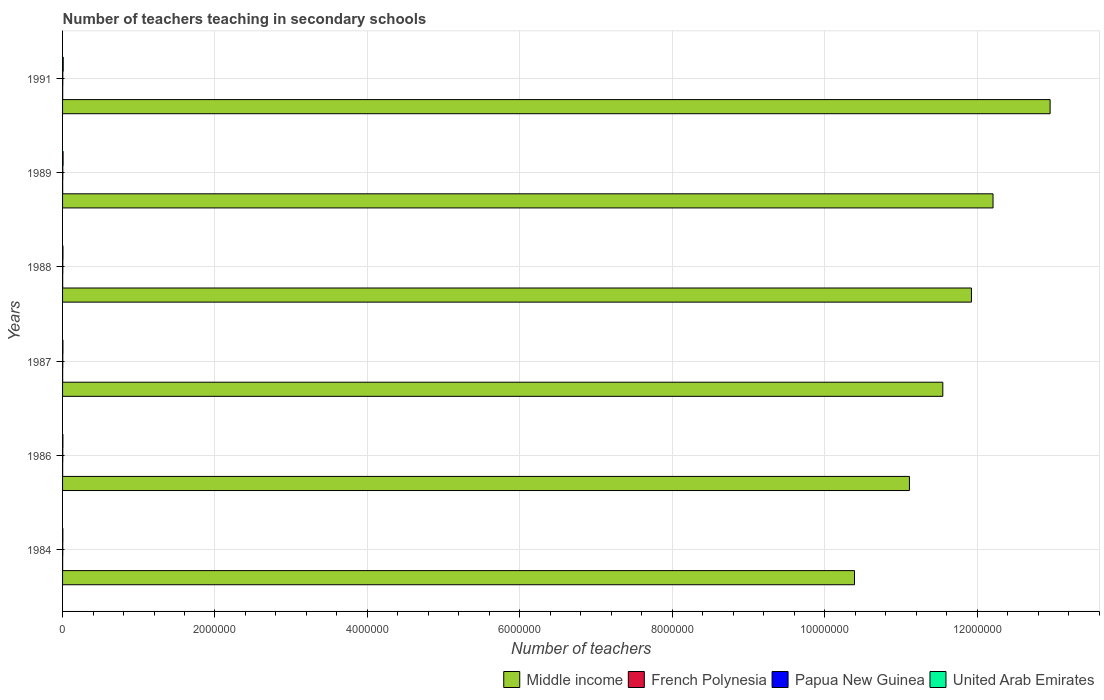How many different coloured bars are there?
Provide a succinct answer. 4. How many groups of bars are there?
Provide a short and direct response. 6. Are the number of bars per tick equal to the number of legend labels?
Provide a succinct answer. Yes. Are the number of bars on each tick of the Y-axis equal?
Offer a very short reply. Yes. How many bars are there on the 1st tick from the bottom?
Keep it short and to the point. 4. In how many cases, is the number of bars for a given year not equal to the number of legend labels?
Ensure brevity in your answer.  0. What is the number of teachers teaching in secondary schools in Middle income in 1988?
Provide a succinct answer. 1.19e+07. Across all years, what is the maximum number of teachers teaching in secondary schools in Middle income?
Provide a short and direct response. 1.30e+07. Across all years, what is the minimum number of teachers teaching in secondary schools in Middle income?
Your response must be concise. 1.04e+07. What is the total number of teachers teaching in secondary schools in Middle income in the graph?
Ensure brevity in your answer.  7.01e+07. What is the difference between the number of teachers teaching in secondary schools in Middle income in 1987 and that in 1991?
Your answer should be compact. -1.41e+06. What is the difference between the number of teachers teaching in secondary schools in Middle income in 1988 and the number of teachers teaching in secondary schools in Papua New Guinea in 1989?
Give a very brief answer. 1.19e+07. What is the average number of teachers teaching in secondary schools in Middle income per year?
Your answer should be compact. 1.17e+07. In the year 1984, what is the difference between the number of teachers teaching in secondary schools in French Polynesia and number of teachers teaching in secondary schools in Papua New Guinea?
Your answer should be compact. -1327. In how many years, is the number of teachers teaching in secondary schools in Papua New Guinea greater than 8400000 ?
Offer a terse response. 0. What is the ratio of the number of teachers teaching in secondary schools in United Arab Emirates in 1987 to that in 1991?
Keep it short and to the point. 0.55. Is the number of teachers teaching in secondary schools in Papua New Guinea in 1986 less than that in 1987?
Provide a short and direct response. Yes. Is the difference between the number of teachers teaching in secondary schools in French Polynesia in 1984 and 1986 greater than the difference between the number of teachers teaching in secondary schools in Papua New Guinea in 1984 and 1986?
Ensure brevity in your answer.  Yes. What is the difference between the highest and the second highest number of teachers teaching in secondary schools in Middle income?
Your answer should be compact. 7.49e+05. What is the difference between the highest and the lowest number of teachers teaching in secondary schools in Middle income?
Offer a very short reply. 2.57e+06. Is the sum of the number of teachers teaching in secondary schools in United Arab Emirates in 1986 and 1989 greater than the maximum number of teachers teaching in secondary schools in Papua New Guinea across all years?
Offer a terse response. Yes. Is it the case that in every year, the sum of the number of teachers teaching in secondary schools in French Polynesia and number of teachers teaching in secondary schools in United Arab Emirates is greater than the sum of number of teachers teaching in secondary schools in Middle income and number of teachers teaching in secondary schools in Papua New Guinea?
Your answer should be compact. No. What does the 1st bar from the top in 1988 represents?
Provide a short and direct response. United Arab Emirates. What does the 1st bar from the bottom in 1991 represents?
Give a very brief answer. Middle income. Is it the case that in every year, the sum of the number of teachers teaching in secondary schools in United Arab Emirates and number of teachers teaching in secondary schools in Papua New Guinea is greater than the number of teachers teaching in secondary schools in French Polynesia?
Provide a succinct answer. Yes. How many bars are there?
Make the answer very short. 24. Does the graph contain any zero values?
Your response must be concise. No. Does the graph contain grids?
Offer a very short reply. Yes. How many legend labels are there?
Provide a short and direct response. 4. What is the title of the graph?
Ensure brevity in your answer.  Number of teachers teaching in secondary schools. What is the label or title of the X-axis?
Keep it short and to the point. Number of teachers. What is the label or title of the Y-axis?
Provide a succinct answer. Years. What is the Number of teachers in Middle income in 1984?
Keep it short and to the point. 1.04e+07. What is the Number of teachers of French Polynesia in 1984?
Offer a terse response. 1051. What is the Number of teachers in Papua New Guinea in 1984?
Offer a terse response. 2378. What is the Number of teachers of United Arab Emirates in 1984?
Your response must be concise. 3735. What is the Number of teachers of Middle income in 1986?
Make the answer very short. 1.11e+07. What is the Number of teachers of French Polynesia in 1986?
Your answer should be very brief. 1208. What is the Number of teachers of Papua New Guinea in 1986?
Your answer should be compact. 2549. What is the Number of teachers in United Arab Emirates in 1986?
Give a very brief answer. 4237. What is the Number of teachers of Middle income in 1987?
Offer a terse response. 1.16e+07. What is the Number of teachers of French Polynesia in 1987?
Provide a succinct answer. 1240. What is the Number of teachers in Papua New Guinea in 1987?
Your answer should be very brief. 2922. What is the Number of teachers in United Arab Emirates in 1987?
Your answer should be compact. 4724. What is the Number of teachers of Middle income in 1988?
Provide a succinct answer. 1.19e+07. What is the Number of teachers in French Polynesia in 1988?
Offer a very short reply. 1296. What is the Number of teachers of Papua New Guinea in 1988?
Make the answer very short. 3064. What is the Number of teachers of United Arab Emirates in 1988?
Ensure brevity in your answer.  5008. What is the Number of teachers in Middle income in 1989?
Your answer should be very brief. 1.22e+07. What is the Number of teachers in French Polynesia in 1989?
Keep it short and to the point. 1290. What is the Number of teachers of Papua New Guinea in 1989?
Provide a short and direct response. 3057. What is the Number of teachers of United Arab Emirates in 1989?
Make the answer very short. 6875. What is the Number of teachers of Middle income in 1991?
Keep it short and to the point. 1.30e+07. What is the Number of teachers in French Polynesia in 1991?
Offer a terse response. 1497. What is the Number of teachers of Papua New Guinea in 1991?
Ensure brevity in your answer.  3120. What is the Number of teachers of United Arab Emirates in 1991?
Provide a succinct answer. 8565. Across all years, what is the maximum Number of teachers of Middle income?
Offer a terse response. 1.30e+07. Across all years, what is the maximum Number of teachers in French Polynesia?
Ensure brevity in your answer.  1497. Across all years, what is the maximum Number of teachers in Papua New Guinea?
Provide a succinct answer. 3120. Across all years, what is the maximum Number of teachers in United Arab Emirates?
Provide a short and direct response. 8565. Across all years, what is the minimum Number of teachers in Middle income?
Provide a succinct answer. 1.04e+07. Across all years, what is the minimum Number of teachers in French Polynesia?
Provide a short and direct response. 1051. Across all years, what is the minimum Number of teachers in Papua New Guinea?
Your answer should be very brief. 2378. Across all years, what is the minimum Number of teachers of United Arab Emirates?
Provide a succinct answer. 3735. What is the total Number of teachers of Middle income in the graph?
Offer a very short reply. 7.01e+07. What is the total Number of teachers of French Polynesia in the graph?
Offer a terse response. 7582. What is the total Number of teachers in Papua New Guinea in the graph?
Provide a short and direct response. 1.71e+04. What is the total Number of teachers in United Arab Emirates in the graph?
Provide a short and direct response. 3.31e+04. What is the difference between the Number of teachers of Middle income in 1984 and that in 1986?
Provide a short and direct response. -7.21e+05. What is the difference between the Number of teachers of French Polynesia in 1984 and that in 1986?
Give a very brief answer. -157. What is the difference between the Number of teachers in Papua New Guinea in 1984 and that in 1986?
Give a very brief answer. -171. What is the difference between the Number of teachers in United Arab Emirates in 1984 and that in 1986?
Your answer should be very brief. -502. What is the difference between the Number of teachers in Middle income in 1984 and that in 1987?
Make the answer very short. -1.16e+06. What is the difference between the Number of teachers of French Polynesia in 1984 and that in 1987?
Provide a short and direct response. -189. What is the difference between the Number of teachers in Papua New Guinea in 1984 and that in 1987?
Offer a very short reply. -544. What is the difference between the Number of teachers in United Arab Emirates in 1984 and that in 1987?
Offer a very short reply. -989. What is the difference between the Number of teachers of Middle income in 1984 and that in 1988?
Provide a succinct answer. -1.53e+06. What is the difference between the Number of teachers in French Polynesia in 1984 and that in 1988?
Your answer should be compact. -245. What is the difference between the Number of teachers of Papua New Guinea in 1984 and that in 1988?
Keep it short and to the point. -686. What is the difference between the Number of teachers in United Arab Emirates in 1984 and that in 1988?
Keep it short and to the point. -1273. What is the difference between the Number of teachers of Middle income in 1984 and that in 1989?
Offer a terse response. -1.82e+06. What is the difference between the Number of teachers in French Polynesia in 1984 and that in 1989?
Ensure brevity in your answer.  -239. What is the difference between the Number of teachers of Papua New Guinea in 1984 and that in 1989?
Your response must be concise. -679. What is the difference between the Number of teachers of United Arab Emirates in 1984 and that in 1989?
Offer a terse response. -3140. What is the difference between the Number of teachers of Middle income in 1984 and that in 1991?
Give a very brief answer. -2.57e+06. What is the difference between the Number of teachers in French Polynesia in 1984 and that in 1991?
Provide a succinct answer. -446. What is the difference between the Number of teachers in Papua New Guinea in 1984 and that in 1991?
Provide a short and direct response. -742. What is the difference between the Number of teachers in United Arab Emirates in 1984 and that in 1991?
Offer a very short reply. -4830. What is the difference between the Number of teachers in Middle income in 1986 and that in 1987?
Provide a short and direct response. -4.38e+05. What is the difference between the Number of teachers in French Polynesia in 1986 and that in 1987?
Provide a short and direct response. -32. What is the difference between the Number of teachers of Papua New Guinea in 1986 and that in 1987?
Provide a short and direct response. -373. What is the difference between the Number of teachers of United Arab Emirates in 1986 and that in 1987?
Provide a short and direct response. -487. What is the difference between the Number of teachers in Middle income in 1986 and that in 1988?
Offer a very short reply. -8.13e+05. What is the difference between the Number of teachers of French Polynesia in 1986 and that in 1988?
Give a very brief answer. -88. What is the difference between the Number of teachers in Papua New Guinea in 1986 and that in 1988?
Offer a terse response. -515. What is the difference between the Number of teachers in United Arab Emirates in 1986 and that in 1988?
Offer a very short reply. -771. What is the difference between the Number of teachers in Middle income in 1986 and that in 1989?
Your answer should be compact. -1.10e+06. What is the difference between the Number of teachers of French Polynesia in 1986 and that in 1989?
Give a very brief answer. -82. What is the difference between the Number of teachers of Papua New Guinea in 1986 and that in 1989?
Your response must be concise. -508. What is the difference between the Number of teachers in United Arab Emirates in 1986 and that in 1989?
Your answer should be very brief. -2638. What is the difference between the Number of teachers in Middle income in 1986 and that in 1991?
Your answer should be very brief. -1.85e+06. What is the difference between the Number of teachers of French Polynesia in 1986 and that in 1991?
Your answer should be compact. -289. What is the difference between the Number of teachers of Papua New Guinea in 1986 and that in 1991?
Your answer should be very brief. -571. What is the difference between the Number of teachers in United Arab Emirates in 1986 and that in 1991?
Provide a succinct answer. -4328. What is the difference between the Number of teachers in Middle income in 1987 and that in 1988?
Your response must be concise. -3.76e+05. What is the difference between the Number of teachers of French Polynesia in 1987 and that in 1988?
Your answer should be compact. -56. What is the difference between the Number of teachers in Papua New Guinea in 1987 and that in 1988?
Ensure brevity in your answer.  -142. What is the difference between the Number of teachers of United Arab Emirates in 1987 and that in 1988?
Provide a short and direct response. -284. What is the difference between the Number of teachers in Middle income in 1987 and that in 1989?
Ensure brevity in your answer.  -6.59e+05. What is the difference between the Number of teachers in French Polynesia in 1987 and that in 1989?
Keep it short and to the point. -50. What is the difference between the Number of teachers in Papua New Guinea in 1987 and that in 1989?
Your response must be concise. -135. What is the difference between the Number of teachers of United Arab Emirates in 1987 and that in 1989?
Ensure brevity in your answer.  -2151. What is the difference between the Number of teachers of Middle income in 1987 and that in 1991?
Your answer should be compact. -1.41e+06. What is the difference between the Number of teachers in French Polynesia in 1987 and that in 1991?
Offer a very short reply. -257. What is the difference between the Number of teachers in Papua New Guinea in 1987 and that in 1991?
Your answer should be compact. -198. What is the difference between the Number of teachers of United Arab Emirates in 1987 and that in 1991?
Ensure brevity in your answer.  -3841. What is the difference between the Number of teachers in Middle income in 1988 and that in 1989?
Your response must be concise. -2.83e+05. What is the difference between the Number of teachers of United Arab Emirates in 1988 and that in 1989?
Give a very brief answer. -1867. What is the difference between the Number of teachers of Middle income in 1988 and that in 1991?
Give a very brief answer. -1.03e+06. What is the difference between the Number of teachers in French Polynesia in 1988 and that in 1991?
Keep it short and to the point. -201. What is the difference between the Number of teachers in Papua New Guinea in 1988 and that in 1991?
Offer a terse response. -56. What is the difference between the Number of teachers in United Arab Emirates in 1988 and that in 1991?
Offer a terse response. -3557. What is the difference between the Number of teachers of Middle income in 1989 and that in 1991?
Your answer should be very brief. -7.49e+05. What is the difference between the Number of teachers in French Polynesia in 1989 and that in 1991?
Your answer should be compact. -207. What is the difference between the Number of teachers in Papua New Guinea in 1989 and that in 1991?
Provide a short and direct response. -63. What is the difference between the Number of teachers in United Arab Emirates in 1989 and that in 1991?
Provide a short and direct response. -1690. What is the difference between the Number of teachers of Middle income in 1984 and the Number of teachers of French Polynesia in 1986?
Offer a terse response. 1.04e+07. What is the difference between the Number of teachers of Middle income in 1984 and the Number of teachers of Papua New Guinea in 1986?
Offer a very short reply. 1.04e+07. What is the difference between the Number of teachers in Middle income in 1984 and the Number of teachers in United Arab Emirates in 1986?
Provide a succinct answer. 1.04e+07. What is the difference between the Number of teachers of French Polynesia in 1984 and the Number of teachers of Papua New Guinea in 1986?
Make the answer very short. -1498. What is the difference between the Number of teachers of French Polynesia in 1984 and the Number of teachers of United Arab Emirates in 1986?
Provide a short and direct response. -3186. What is the difference between the Number of teachers in Papua New Guinea in 1984 and the Number of teachers in United Arab Emirates in 1986?
Provide a succinct answer. -1859. What is the difference between the Number of teachers of Middle income in 1984 and the Number of teachers of French Polynesia in 1987?
Keep it short and to the point. 1.04e+07. What is the difference between the Number of teachers in Middle income in 1984 and the Number of teachers in Papua New Guinea in 1987?
Provide a short and direct response. 1.04e+07. What is the difference between the Number of teachers in Middle income in 1984 and the Number of teachers in United Arab Emirates in 1987?
Provide a short and direct response. 1.04e+07. What is the difference between the Number of teachers in French Polynesia in 1984 and the Number of teachers in Papua New Guinea in 1987?
Give a very brief answer. -1871. What is the difference between the Number of teachers of French Polynesia in 1984 and the Number of teachers of United Arab Emirates in 1987?
Give a very brief answer. -3673. What is the difference between the Number of teachers in Papua New Guinea in 1984 and the Number of teachers in United Arab Emirates in 1987?
Ensure brevity in your answer.  -2346. What is the difference between the Number of teachers of Middle income in 1984 and the Number of teachers of French Polynesia in 1988?
Offer a terse response. 1.04e+07. What is the difference between the Number of teachers in Middle income in 1984 and the Number of teachers in Papua New Guinea in 1988?
Keep it short and to the point. 1.04e+07. What is the difference between the Number of teachers of Middle income in 1984 and the Number of teachers of United Arab Emirates in 1988?
Your response must be concise. 1.04e+07. What is the difference between the Number of teachers in French Polynesia in 1984 and the Number of teachers in Papua New Guinea in 1988?
Offer a very short reply. -2013. What is the difference between the Number of teachers of French Polynesia in 1984 and the Number of teachers of United Arab Emirates in 1988?
Provide a succinct answer. -3957. What is the difference between the Number of teachers in Papua New Guinea in 1984 and the Number of teachers in United Arab Emirates in 1988?
Give a very brief answer. -2630. What is the difference between the Number of teachers in Middle income in 1984 and the Number of teachers in French Polynesia in 1989?
Give a very brief answer. 1.04e+07. What is the difference between the Number of teachers in Middle income in 1984 and the Number of teachers in Papua New Guinea in 1989?
Offer a terse response. 1.04e+07. What is the difference between the Number of teachers in Middle income in 1984 and the Number of teachers in United Arab Emirates in 1989?
Your answer should be very brief. 1.04e+07. What is the difference between the Number of teachers in French Polynesia in 1984 and the Number of teachers in Papua New Guinea in 1989?
Provide a short and direct response. -2006. What is the difference between the Number of teachers in French Polynesia in 1984 and the Number of teachers in United Arab Emirates in 1989?
Offer a terse response. -5824. What is the difference between the Number of teachers of Papua New Guinea in 1984 and the Number of teachers of United Arab Emirates in 1989?
Give a very brief answer. -4497. What is the difference between the Number of teachers of Middle income in 1984 and the Number of teachers of French Polynesia in 1991?
Offer a terse response. 1.04e+07. What is the difference between the Number of teachers in Middle income in 1984 and the Number of teachers in Papua New Guinea in 1991?
Provide a short and direct response. 1.04e+07. What is the difference between the Number of teachers of Middle income in 1984 and the Number of teachers of United Arab Emirates in 1991?
Provide a succinct answer. 1.04e+07. What is the difference between the Number of teachers of French Polynesia in 1984 and the Number of teachers of Papua New Guinea in 1991?
Offer a very short reply. -2069. What is the difference between the Number of teachers in French Polynesia in 1984 and the Number of teachers in United Arab Emirates in 1991?
Your answer should be very brief. -7514. What is the difference between the Number of teachers of Papua New Guinea in 1984 and the Number of teachers of United Arab Emirates in 1991?
Give a very brief answer. -6187. What is the difference between the Number of teachers in Middle income in 1986 and the Number of teachers in French Polynesia in 1987?
Offer a terse response. 1.11e+07. What is the difference between the Number of teachers in Middle income in 1986 and the Number of teachers in Papua New Guinea in 1987?
Offer a very short reply. 1.11e+07. What is the difference between the Number of teachers of Middle income in 1986 and the Number of teachers of United Arab Emirates in 1987?
Your answer should be very brief. 1.11e+07. What is the difference between the Number of teachers in French Polynesia in 1986 and the Number of teachers in Papua New Guinea in 1987?
Give a very brief answer. -1714. What is the difference between the Number of teachers of French Polynesia in 1986 and the Number of teachers of United Arab Emirates in 1987?
Ensure brevity in your answer.  -3516. What is the difference between the Number of teachers in Papua New Guinea in 1986 and the Number of teachers in United Arab Emirates in 1987?
Provide a short and direct response. -2175. What is the difference between the Number of teachers in Middle income in 1986 and the Number of teachers in French Polynesia in 1988?
Ensure brevity in your answer.  1.11e+07. What is the difference between the Number of teachers of Middle income in 1986 and the Number of teachers of Papua New Guinea in 1988?
Keep it short and to the point. 1.11e+07. What is the difference between the Number of teachers of Middle income in 1986 and the Number of teachers of United Arab Emirates in 1988?
Your answer should be very brief. 1.11e+07. What is the difference between the Number of teachers in French Polynesia in 1986 and the Number of teachers in Papua New Guinea in 1988?
Give a very brief answer. -1856. What is the difference between the Number of teachers of French Polynesia in 1986 and the Number of teachers of United Arab Emirates in 1988?
Offer a very short reply. -3800. What is the difference between the Number of teachers in Papua New Guinea in 1986 and the Number of teachers in United Arab Emirates in 1988?
Your answer should be very brief. -2459. What is the difference between the Number of teachers of Middle income in 1986 and the Number of teachers of French Polynesia in 1989?
Provide a succinct answer. 1.11e+07. What is the difference between the Number of teachers in Middle income in 1986 and the Number of teachers in Papua New Guinea in 1989?
Provide a succinct answer. 1.11e+07. What is the difference between the Number of teachers of Middle income in 1986 and the Number of teachers of United Arab Emirates in 1989?
Ensure brevity in your answer.  1.11e+07. What is the difference between the Number of teachers of French Polynesia in 1986 and the Number of teachers of Papua New Guinea in 1989?
Offer a very short reply. -1849. What is the difference between the Number of teachers in French Polynesia in 1986 and the Number of teachers in United Arab Emirates in 1989?
Give a very brief answer. -5667. What is the difference between the Number of teachers in Papua New Guinea in 1986 and the Number of teachers in United Arab Emirates in 1989?
Provide a short and direct response. -4326. What is the difference between the Number of teachers in Middle income in 1986 and the Number of teachers in French Polynesia in 1991?
Your answer should be compact. 1.11e+07. What is the difference between the Number of teachers of Middle income in 1986 and the Number of teachers of Papua New Guinea in 1991?
Your answer should be compact. 1.11e+07. What is the difference between the Number of teachers of Middle income in 1986 and the Number of teachers of United Arab Emirates in 1991?
Your response must be concise. 1.11e+07. What is the difference between the Number of teachers of French Polynesia in 1986 and the Number of teachers of Papua New Guinea in 1991?
Provide a short and direct response. -1912. What is the difference between the Number of teachers in French Polynesia in 1986 and the Number of teachers in United Arab Emirates in 1991?
Give a very brief answer. -7357. What is the difference between the Number of teachers of Papua New Guinea in 1986 and the Number of teachers of United Arab Emirates in 1991?
Your answer should be compact. -6016. What is the difference between the Number of teachers of Middle income in 1987 and the Number of teachers of French Polynesia in 1988?
Give a very brief answer. 1.15e+07. What is the difference between the Number of teachers in Middle income in 1987 and the Number of teachers in Papua New Guinea in 1988?
Make the answer very short. 1.15e+07. What is the difference between the Number of teachers in Middle income in 1987 and the Number of teachers in United Arab Emirates in 1988?
Your answer should be compact. 1.15e+07. What is the difference between the Number of teachers of French Polynesia in 1987 and the Number of teachers of Papua New Guinea in 1988?
Ensure brevity in your answer.  -1824. What is the difference between the Number of teachers of French Polynesia in 1987 and the Number of teachers of United Arab Emirates in 1988?
Ensure brevity in your answer.  -3768. What is the difference between the Number of teachers in Papua New Guinea in 1987 and the Number of teachers in United Arab Emirates in 1988?
Your answer should be compact. -2086. What is the difference between the Number of teachers in Middle income in 1987 and the Number of teachers in French Polynesia in 1989?
Provide a short and direct response. 1.15e+07. What is the difference between the Number of teachers in Middle income in 1987 and the Number of teachers in Papua New Guinea in 1989?
Offer a very short reply. 1.15e+07. What is the difference between the Number of teachers of Middle income in 1987 and the Number of teachers of United Arab Emirates in 1989?
Your answer should be compact. 1.15e+07. What is the difference between the Number of teachers in French Polynesia in 1987 and the Number of teachers in Papua New Guinea in 1989?
Your answer should be very brief. -1817. What is the difference between the Number of teachers in French Polynesia in 1987 and the Number of teachers in United Arab Emirates in 1989?
Offer a very short reply. -5635. What is the difference between the Number of teachers in Papua New Guinea in 1987 and the Number of teachers in United Arab Emirates in 1989?
Make the answer very short. -3953. What is the difference between the Number of teachers of Middle income in 1987 and the Number of teachers of French Polynesia in 1991?
Provide a succinct answer. 1.15e+07. What is the difference between the Number of teachers of Middle income in 1987 and the Number of teachers of Papua New Guinea in 1991?
Offer a very short reply. 1.15e+07. What is the difference between the Number of teachers of Middle income in 1987 and the Number of teachers of United Arab Emirates in 1991?
Ensure brevity in your answer.  1.15e+07. What is the difference between the Number of teachers in French Polynesia in 1987 and the Number of teachers in Papua New Guinea in 1991?
Make the answer very short. -1880. What is the difference between the Number of teachers of French Polynesia in 1987 and the Number of teachers of United Arab Emirates in 1991?
Make the answer very short. -7325. What is the difference between the Number of teachers in Papua New Guinea in 1987 and the Number of teachers in United Arab Emirates in 1991?
Provide a short and direct response. -5643. What is the difference between the Number of teachers of Middle income in 1988 and the Number of teachers of French Polynesia in 1989?
Make the answer very short. 1.19e+07. What is the difference between the Number of teachers of Middle income in 1988 and the Number of teachers of Papua New Guinea in 1989?
Offer a very short reply. 1.19e+07. What is the difference between the Number of teachers in Middle income in 1988 and the Number of teachers in United Arab Emirates in 1989?
Ensure brevity in your answer.  1.19e+07. What is the difference between the Number of teachers in French Polynesia in 1988 and the Number of teachers in Papua New Guinea in 1989?
Your response must be concise. -1761. What is the difference between the Number of teachers of French Polynesia in 1988 and the Number of teachers of United Arab Emirates in 1989?
Give a very brief answer. -5579. What is the difference between the Number of teachers in Papua New Guinea in 1988 and the Number of teachers in United Arab Emirates in 1989?
Your response must be concise. -3811. What is the difference between the Number of teachers of Middle income in 1988 and the Number of teachers of French Polynesia in 1991?
Provide a succinct answer. 1.19e+07. What is the difference between the Number of teachers in Middle income in 1988 and the Number of teachers in Papua New Guinea in 1991?
Your answer should be compact. 1.19e+07. What is the difference between the Number of teachers of Middle income in 1988 and the Number of teachers of United Arab Emirates in 1991?
Ensure brevity in your answer.  1.19e+07. What is the difference between the Number of teachers of French Polynesia in 1988 and the Number of teachers of Papua New Guinea in 1991?
Provide a succinct answer. -1824. What is the difference between the Number of teachers of French Polynesia in 1988 and the Number of teachers of United Arab Emirates in 1991?
Offer a terse response. -7269. What is the difference between the Number of teachers in Papua New Guinea in 1988 and the Number of teachers in United Arab Emirates in 1991?
Ensure brevity in your answer.  -5501. What is the difference between the Number of teachers of Middle income in 1989 and the Number of teachers of French Polynesia in 1991?
Your answer should be compact. 1.22e+07. What is the difference between the Number of teachers in Middle income in 1989 and the Number of teachers in Papua New Guinea in 1991?
Provide a succinct answer. 1.22e+07. What is the difference between the Number of teachers of Middle income in 1989 and the Number of teachers of United Arab Emirates in 1991?
Provide a short and direct response. 1.22e+07. What is the difference between the Number of teachers of French Polynesia in 1989 and the Number of teachers of Papua New Guinea in 1991?
Make the answer very short. -1830. What is the difference between the Number of teachers in French Polynesia in 1989 and the Number of teachers in United Arab Emirates in 1991?
Offer a terse response. -7275. What is the difference between the Number of teachers in Papua New Guinea in 1989 and the Number of teachers in United Arab Emirates in 1991?
Provide a succinct answer. -5508. What is the average Number of teachers of Middle income per year?
Ensure brevity in your answer.  1.17e+07. What is the average Number of teachers of French Polynesia per year?
Your answer should be very brief. 1263.67. What is the average Number of teachers in Papua New Guinea per year?
Ensure brevity in your answer.  2848.33. What is the average Number of teachers in United Arab Emirates per year?
Make the answer very short. 5524. In the year 1984, what is the difference between the Number of teachers in Middle income and Number of teachers in French Polynesia?
Keep it short and to the point. 1.04e+07. In the year 1984, what is the difference between the Number of teachers in Middle income and Number of teachers in Papua New Guinea?
Give a very brief answer. 1.04e+07. In the year 1984, what is the difference between the Number of teachers of Middle income and Number of teachers of United Arab Emirates?
Your answer should be compact. 1.04e+07. In the year 1984, what is the difference between the Number of teachers of French Polynesia and Number of teachers of Papua New Guinea?
Make the answer very short. -1327. In the year 1984, what is the difference between the Number of teachers in French Polynesia and Number of teachers in United Arab Emirates?
Your response must be concise. -2684. In the year 1984, what is the difference between the Number of teachers of Papua New Guinea and Number of teachers of United Arab Emirates?
Offer a terse response. -1357. In the year 1986, what is the difference between the Number of teachers in Middle income and Number of teachers in French Polynesia?
Offer a very short reply. 1.11e+07. In the year 1986, what is the difference between the Number of teachers in Middle income and Number of teachers in Papua New Guinea?
Your answer should be compact. 1.11e+07. In the year 1986, what is the difference between the Number of teachers in Middle income and Number of teachers in United Arab Emirates?
Your response must be concise. 1.11e+07. In the year 1986, what is the difference between the Number of teachers in French Polynesia and Number of teachers in Papua New Guinea?
Offer a very short reply. -1341. In the year 1986, what is the difference between the Number of teachers of French Polynesia and Number of teachers of United Arab Emirates?
Provide a succinct answer. -3029. In the year 1986, what is the difference between the Number of teachers of Papua New Guinea and Number of teachers of United Arab Emirates?
Offer a terse response. -1688. In the year 1987, what is the difference between the Number of teachers of Middle income and Number of teachers of French Polynesia?
Give a very brief answer. 1.15e+07. In the year 1987, what is the difference between the Number of teachers of Middle income and Number of teachers of Papua New Guinea?
Ensure brevity in your answer.  1.15e+07. In the year 1987, what is the difference between the Number of teachers of Middle income and Number of teachers of United Arab Emirates?
Your answer should be compact. 1.15e+07. In the year 1987, what is the difference between the Number of teachers in French Polynesia and Number of teachers in Papua New Guinea?
Your answer should be compact. -1682. In the year 1987, what is the difference between the Number of teachers of French Polynesia and Number of teachers of United Arab Emirates?
Ensure brevity in your answer.  -3484. In the year 1987, what is the difference between the Number of teachers in Papua New Guinea and Number of teachers in United Arab Emirates?
Make the answer very short. -1802. In the year 1988, what is the difference between the Number of teachers of Middle income and Number of teachers of French Polynesia?
Your answer should be very brief. 1.19e+07. In the year 1988, what is the difference between the Number of teachers in Middle income and Number of teachers in Papua New Guinea?
Keep it short and to the point. 1.19e+07. In the year 1988, what is the difference between the Number of teachers of Middle income and Number of teachers of United Arab Emirates?
Provide a succinct answer. 1.19e+07. In the year 1988, what is the difference between the Number of teachers of French Polynesia and Number of teachers of Papua New Guinea?
Keep it short and to the point. -1768. In the year 1988, what is the difference between the Number of teachers in French Polynesia and Number of teachers in United Arab Emirates?
Make the answer very short. -3712. In the year 1988, what is the difference between the Number of teachers in Papua New Guinea and Number of teachers in United Arab Emirates?
Make the answer very short. -1944. In the year 1989, what is the difference between the Number of teachers in Middle income and Number of teachers in French Polynesia?
Keep it short and to the point. 1.22e+07. In the year 1989, what is the difference between the Number of teachers in Middle income and Number of teachers in Papua New Guinea?
Your answer should be compact. 1.22e+07. In the year 1989, what is the difference between the Number of teachers of Middle income and Number of teachers of United Arab Emirates?
Offer a terse response. 1.22e+07. In the year 1989, what is the difference between the Number of teachers in French Polynesia and Number of teachers in Papua New Guinea?
Keep it short and to the point. -1767. In the year 1989, what is the difference between the Number of teachers in French Polynesia and Number of teachers in United Arab Emirates?
Your answer should be compact. -5585. In the year 1989, what is the difference between the Number of teachers of Papua New Guinea and Number of teachers of United Arab Emirates?
Make the answer very short. -3818. In the year 1991, what is the difference between the Number of teachers in Middle income and Number of teachers in French Polynesia?
Offer a very short reply. 1.30e+07. In the year 1991, what is the difference between the Number of teachers of Middle income and Number of teachers of Papua New Guinea?
Provide a short and direct response. 1.30e+07. In the year 1991, what is the difference between the Number of teachers in Middle income and Number of teachers in United Arab Emirates?
Your answer should be very brief. 1.29e+07. In the year 1991, what is the difference between the Number of teachers of French Polynesia and Number of teachers of Papua New Guinea?
Ensure brevity in your answer.  -1623. In the year 1991, what is the difference between the Number of teachers in French Polynesia and Number of teachers in United Arab Emirates?
Your answer should be compact. -7068. In the year 1991, what is the difference between the Number of teachers in Papua New Guinea and Number of teachers in United Arab Emirates?
Keep it short and to the point. -5445. What is the ratio of the Number of teachers of Middle income in 1984 to that in 1986?
Make the answer very short. 0.94. What is the ratio of the Number of teachers in French Polynesia in 1984 to that in 1986?
Ensure brevity in your answer.  0.87. What is the ratio of the Number of teachers in Papua New Guinea in 1984 to that in 1986?
Offer a terse response. 0.93. What is the ratio of the Number of teachers of United Arab Emirates in 1984 to that in 1986?
Make the answer very short. 0.88. What is the ratio of the Number of teachers of Middle income in 1984 to that in 1987?
Make the answer very short. 0.9. What is the ratio of the Number of teachers in French Polynesia in 1984 to that in 1987?
Your response must be concise. 0.85. What is the ratio of the Number of teachers in Papua New Guinea in 1984 to that in 1987?
Ensure brevity in your answer.  0.81. What is the ratio of the Number of teachers of United Arab Emirates in 1984 to that in 1987?
Your answer should be very brief. 0.79. What is the ratio of the Number of teachers of Middle income in 1984 to that in 1988?
Offer a very short reply. 0.87. What is the ratio of the Number of teachers in French Polynesia in 1984 to that in 1988?
Your answer should be compact. 0.81. What is the ratio of the Number of teachers in Papua New Guinea in 1984 to that in 1988?
Keep it short and to the point. 0.78. What is the ratio of the Number of teachers of United Arab Emirates in 1984 to that in 1988?
Give a very brief answer. 0.75. What is the ratio of the Number of teachers of Middle income in 1984 to that in 1989?
Provide a short and direct response. 0.85. What is the ratio of the Number of teachers of French Polynesia in 1984 to that in 1989?
Your answer should be compact. 0.81. What is the ratio of the Number of teachers of Papua New Guinea in 1984 to that in 1989?
Give a very brief answer. 0.78. What is the ratio of the Number of teachers in United Arab Emirates in 1984 to that in 1989?
Ensure brevity in your answer.  0.54. What is the ratio of the Number of teachers of Middle income in 1984 to that in 1991?
Your answer should be very brief. 0.8. What is the ratio of the Number of teachers of French Polynesia in 1984 to that in 1991?
Provide a short and direct response. 0.7. What is the ratio of the Number of teachers of Papua New Guinea in 1984 to that in 1991?
Your answer should be compact. 0.76. What is the ratio of the Number of teachers in United Arab Emirates in 1984 to that in 1991?
Your answer should be very brief. 0.44. What is the ratio of the Number of teachers in Middle income in 1986 to that in 1987?
Make the answer very short. 0.96. What is the ratio of the Number of teachers of French Polynesia in 1986 to that in 1987?
Provide a short and direct response. 0.97. What is the ratio of the Number of teachers in Papua New Guinea in 1986 to that in 1987?
Make the answer very short. 0.87. What is the ratio of the Number of teachers in United Arab Emirates in 1986 to that in 1987?
Provide a short and direct response. 0.9. What is the ratio of the Number of teachers in Middle income in 1986 to that in 1988?
Ensure brevity in your answer.  0.93. What is the ratio of the Number of teachers of French Polynesia in 1986 to that in 1988?
Provide a succinct answer. 0.93. What is the ratio of the Number of teachers of Papua New Guinea in 1986 to that in 1988?
Make the answer very short. 0.83. What is the ratio of the Number of teachers of United Arab Emirates in 1986 to that in 1988?
Your answer should be very brief. 0.85. What is the ratio of the Number of teachers of Middle income in 1986 to that in 1989?
Your answer should be very brief. 0.91. What is the ratio of the Number of teachers in French Polynesia in 1986 to that in 1989?
Keep it short and to the point. 0.94. What is the ratio of the Number of teachers in Papua New Guinea in 1986 to that in 1989?
Your answer should be compact. 0.83. What is the ratio of the Number of teachers in United Arab Emirates in 1986 to that in 1989?
Give a very brief answer. 0.62. What is the ratio of the Number of teachers of Middle income in 1986 to that in 1991?
Your response must be concise. 0.86. What is the ratio of the Number of teachers in French Polynesia in 1986 to that in 1991?
Offer a very short reply. 0.81. What is the ratio of the Number of teachers in Papua New Guinea in 1986 to that in 1991?
Ensure brevity in your answer.  0.82. What is the ratio of the Number of teachers of United Arab Emirates in 1986 to that in 1991?
Keep it short and to the point. 0.49. What is the ratio of the Number of teachers of Middle income in 1987 to that in 1988?
Keep it short and to the point. 0.97. What is the ratio of the Number of teachers of French Polynesia in 1987 to that in 1988?
Your answer should be compact. 0.96. What is the ratio of the Number of teachers in Papua New Guinea in 1987 to that in 1988?
Offer a very short reply. 0.95. What is the ratio of the Number of teachers in United Arab Emirates in 1987 to that in 1988?
Keep it short and to the point. 0.94. What is the ratio of the Number of teachers in Middle income in 1987 to that in 1989?
Your response must be concise. 0.95. What is the ratio of the Number of teachers in French Polynesia in 1987 to that in 1989?
Give a very brief answer. 0.96. What is the ratio of the Number of teachers in Papua New Guinea in 1987 to that in 1989?
Your response must be concise. 0.96. What is the ratio of the Number of teachers in United Arab Emirates in 1987 to that in 1989?
Provide a succinct answer. 0.69. What is the ratio of the Number of teachers of Middle income in 1987 to that in 1991?
Your answer should be compact. 0.89. What is the ratio of the Number of teachers in French Polynesia in 1987 to that in 1991?
Your answer should be compact. 0.83. What is the ratio of the Number of teachers in Papua New Guinea in 1987 to that in 1991?
Your response must be concise. 0.94. What is the ratio of the Number of teachers in United Arab Emirates in 1987 to that in 1991?
Offer a terse response. 0.55. What is the ratio of the Number of teachers in Middle income in 1988 to that in 1989?
Your answer should be compact. 0.98. What is the ratio of the Number of teachers of Papua New Guinea in 1988 to that in 1989?
Keep it short and to the point. 1. What is the ratio of the Number of teachers in United Arab Emirates in 1988 to that in 1989?
Your response must be concise. 0.73. What is the ratio of the Number of teachers of Middle income in 1988 to that in 1991?
Make the answer very short. 0.92. What is the ratio of the Number of teachers in French Polynesia in 1988 to that in 1991?
Give a very brief answer. 0.87. What is the ratio of the Number of teachers in Papua New Guinea in 1988 to that in 1991?
Offer a very short reply. 0.98. What is the ratio of the Number of teachers of United Arab Emirates in 1988 to that in 1991?
Give a very brief answer. 0.58. What is the ratio of the Number of teachers of Middle income in 1989 to that in 1991?
Your answer should be compact. 0.94. What is the ratio of the Number of teachers of French Polynesia in 1989 to that in 1991?
Your answer should be compact. 0.86. What is the ratio of the Number of teachers of Papua New Guinea in 1989 to that in 1991?
Your answer should be very brief. 0.98. What is the ratio of the Number of teachers of United Arab Emirates in 1989 to that in 1991?
Keep it short and to the point. 0.8. What is the difference between the highest and the second highest Number of teachers in Middle income?
Offer a very short reply. 7.49e+05. What is the difference between the highest and the second highest Number of teachers of French Polynesia?
Provide a succinct answer. 201. What is the difference between the highest and the second highest Number of teachers of Papua New Guinea?
Offer a terse response. 56. What is the difference between the highest and the second highest Number of teachers of United Arab Emirates?
Offer a terse response. 1690. What is the difference between the highest and the lowest Number of teachers in Middle income?
Your response must be concise. 2.57e+06. What is the difference between the highest and the lowest Number of teachers in French Polynesia?
Give a very brief answer. 446. What is the difference between the highest and the lowest Number of teachers in Papua New Guinea?
Provide a succinct answer. 742. What is the difference between the highest and the lowest Number of teachers in United Arab Emirates?
Your answer should be compact. 4830. 